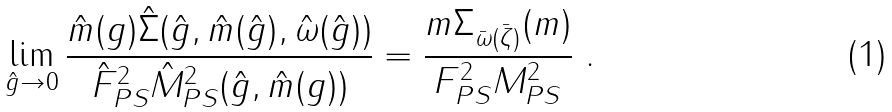<formula> <loc_0><loc_0><loc_500><loc_500>\lim _ { \hat { g } \to 0 } \frac { \hat { m } ( g ) \hat { \Sigma } ( \hat { g } , \hat { m } ( \hat { g } ) , \hat { \omega } ( \hat { g } ) ) } { \hat { F } _ { P S } ^ { 2 } \hat { M } _ { P S } ^ { 2 } ( \hat { g } , \hat { m } ( g ) ) } = \frac { m \Sigma _ { \bar { \omega } ( \bar { \zeta } ) } ( m ) } { F _ { P S } ^ { 2 } M _ { P S } ^ { 2 } } \ .</formula> 